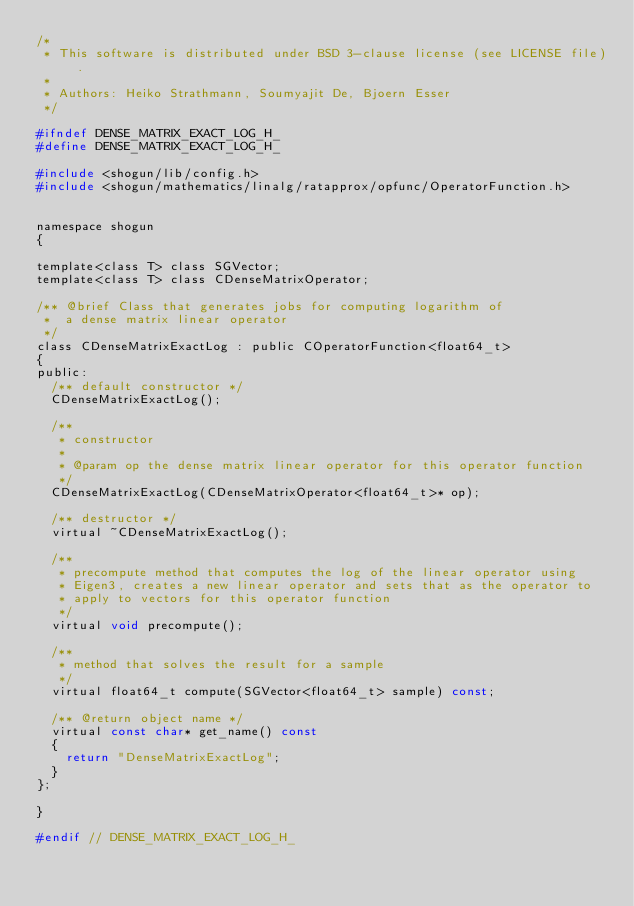<code> <loc_0><loc_0><loc_500><loc_500><_C_>/*
 * This software is distributed under BSD 3-clause license (see LICENSE file).
 *
 * Authors: Heiko Strathmann, Soumyajit De, Bjoern Esser
 */

#ifndef DENSE_MATRIX_EXACT_LOG_H_
#define DENSE_MATRIX_EXACT_LOG_H_

#include <shogun/lib/config.h>
#include <shogun/mathematics/linalg/ratapprox/opfunc/OperatorFunction.h>


namespace shogun
{

template<class T> class SGVector;
template<class T> class CDenseMatrixOperator;

/** @brief Class that generates jobs for computing logarithm of
 *  a dense matrix linear operator
 */
class CDenseMatrixExactLog : public COperatorFunction<float64_t>
{
public:
	/** default constructor */
	CDenseMatrixExactLog();

	/**
	 * constructor
	 *
	 * @param op the dense matrix linear operator for this operator function
	 */
	CDenseMatrixExactLog(CDenseMatrixOperator<float64_t>* op);

	/** destructor */
	virtual ~CDenseMatrixExactLog();

	/**
	 * precompute method that computes the log of the linear operator using
	 * Eigen3, creates a new linear operator and sets that as the operator to
	 * apply to vectors for this operator function
	 */
	virtual void precompute();

	/**
	 * method that solves the result for a sample
	 */
	virtual float64_t compute(SGVector<float64_t> sample) const;

	/** @return object name */
	virtual const char* get_name() const
	{
		return "DenseMatrixExactLog";
	}
};

}

#endif // DENSE_MATRIX_EXACT_LOG_H_
</code> 